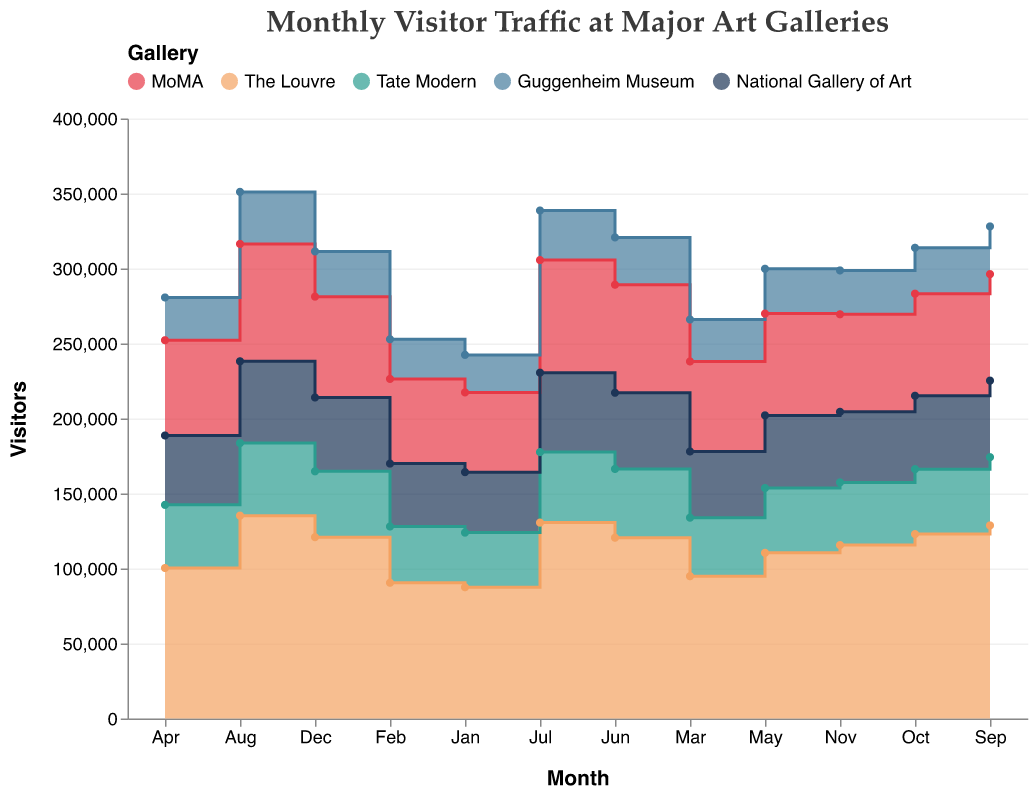What is the title of the chart? The title is directly visible in the chart and usually appears at the top. The title summarizes what the chart is about.
Answer: Monthly Visitor Traffic at Major Art Galleries How many months of data are presented in the chart? By examining the x-axis, we can see it lists all months from January to December, totaling 12 months.
Answer: 12 Which gallery had the highest visitor traffic in August? To determine this, look at the data points for August along the x-axis for each gallery line and identify the one with the highest value.
Answer: The Louvre What is the color associated with MoMA in the chart? The color legend at the top of the chart indicates the corresponding color for each gallery.
Answer: Red Which gallery had the least visitor traffic in February? Check the data points for February along the x-axis for each gallery line and find the one with the smallest value.
Answer: Guggenheim Museum Calculate the average visitor traffic for the National Gallery of Art over the whole year. Sum up the monthly visitor counts for the National Gallery of Art and divide by 12: (40329 + 41960 + 44120 + 46250 + 48430 + 50785 + 52920 + 54500 + 51050 + 48920 + 47050 + 49200) / 12 = 51501.25.
Answer: 51501.25 Which months did The Louvre experience its highest visitor traffic? Find the data points where The Louvre had the highest values along the y-axis and trace these points back to their corresponding months on the x-axis.
Answer: August Between which months did MoMA see the highest increase in visitor traffic? Calculate the differences in visitor counts between each pair of consecutive months for MoMA and identify the pair with the largest increase.
Answer: May to June On average, which gallery saw the highest monthly visitor traffic? Calculate the average monthly visitor count for each gallery by summing their visitor counts and dividing by 12, then compare the averages to find the highest one.
Answer: The Louvre Based on the overall trend, does the visitor traffic for Tate Modern increase or decrease towards the end of the year? Analyze the slope of Tate Modern's line toward the end of the year from September to December to see if it is increasing or decreasing.
Answer: Decreasing 